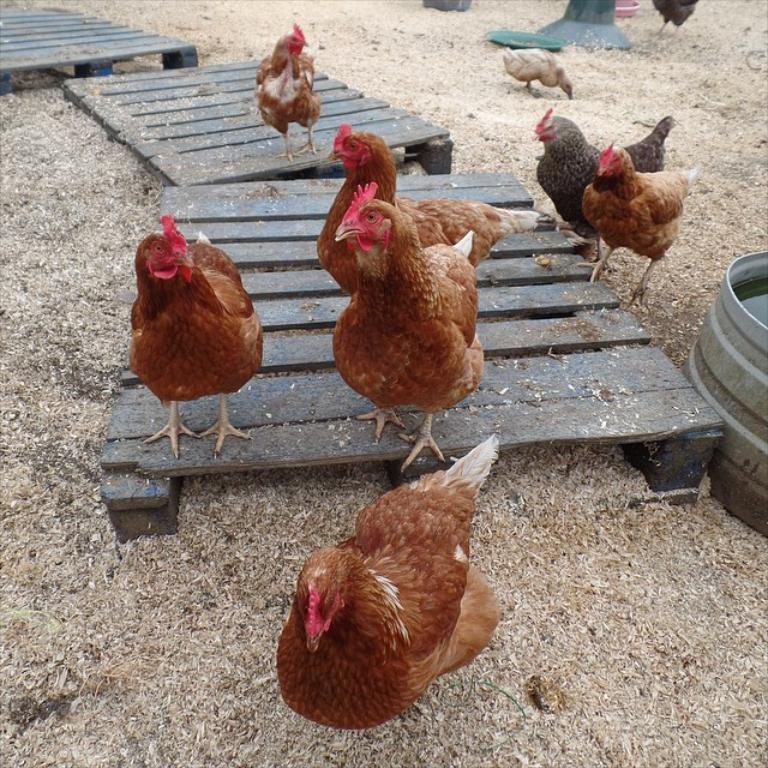What type of animals can be seen on the wooden surface in the image? There are many hens on a wooden surface in the image. What object is located on the right side of the image? There is a drum on the right side of the image. Can you describe the background of the image? In the background, there are a few more objects on the ground. What type of lumber is being used to construct the question in the image? There is no question present in the image, and therefore no lumber is being used to construct it. 